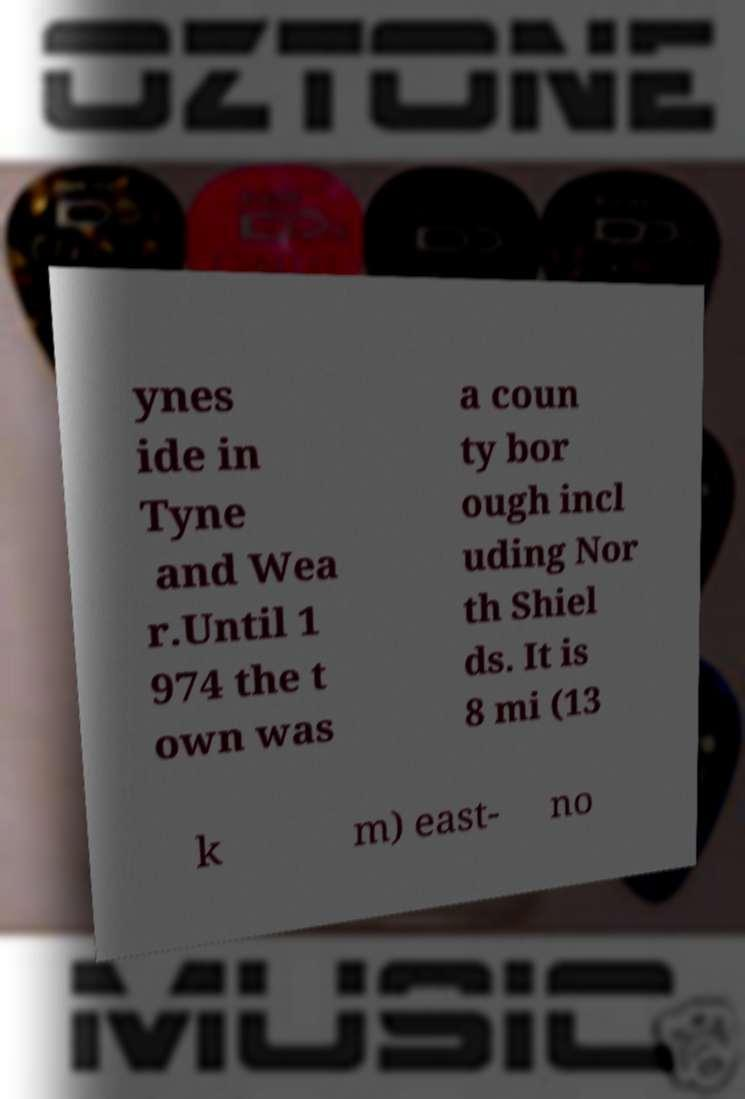Could you extract and type out the text from this image? ynes ide in Tyne and Wea r.Until 1 974 the t own was a coun ty bor ough incl uding Nor th Shiel ds. It is 8 mi (13 k m) east- no 